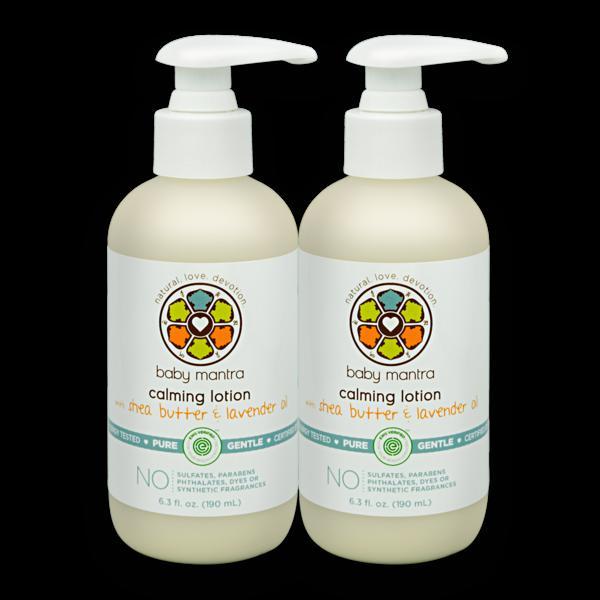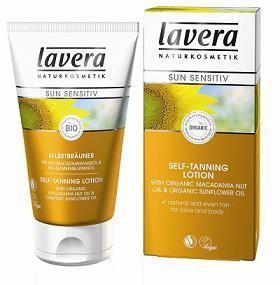The first image is the image on the left, the second image is the image on the right. Examine the images to the left and right. Is the description "An image features two unwrapped pump bottles with nozzles turned rightward." accurate? Answer yes or no. Yes. The first image is the image on the left, the second image is the image on the right. Analyze the images presented: Is the assertion "There are two dispensers pointing right in one of the images." valid? Answer yes or no. Yes. 